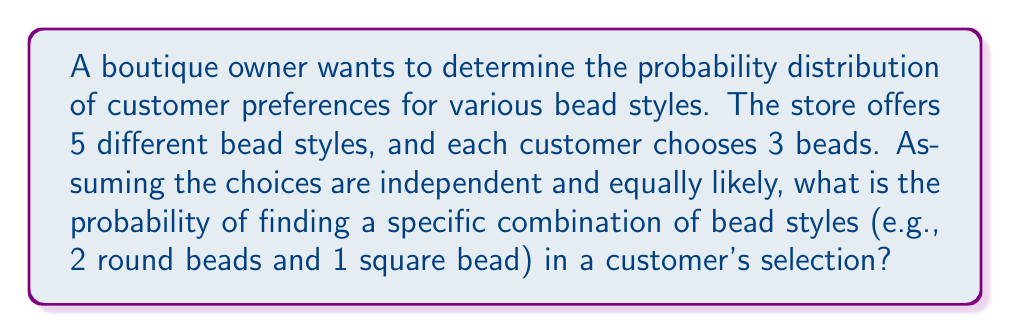Help me with this question. To solve this problem, we'll use concepts from statistical mechanics, specifically the multinomial distribution.

Step 1: Define the system
- Total number of bead styles: $N = 5$
- Number of beads chosen by each customer: $n = 3$

Step 2: Calculate the total number of possible combinations
The total number of ways to choose 3 beads from 5 styles with replacement is:
$$ \Omega = N^n = 5^3 = 125 $$

Step 3: Calculate the probability of a specific combination
For the example of 2 round beads and 1 square bead:
- Number of ways to arrange this combination: $\binom{3}{2,1} = \frac{3!}{2!1!} = 3$
- Probability of choosing each bead: $p_{\text{round}} = p_{\text{square}} = \frac{1}{5}$

The probability of this specific combination is:
$$ P = \binom{3}{2,1} \cdot \left(\frac{1}{5}\right)^2 \cdot \left(\frac{1}{5}\right)^1 \cdot 3 = \frac{3}{125} = 0.024 $$

Step 4: Generalize the formula
For any combination of bead styles $(n_1, n_2, ..., n_k)$ where $\sum_{i=1}^k n_i = n$:

$$ P = \frac{n!}{n_1! n_2! ... n_k!} \cdot \prod_{i=1}^k \left(\frac{1}{N}\right)^{n_i} $$

This formula represents the probability distribution of customer preferences for various bead styles using the multinomial distribution, which is an extension of the binomial distribution to multiple categories.
Answer: $P = \frac{n!}{n_1! n_2! ... n_k!} \cdot \prod_{i=1}^k \left(\frac{1}{N}\right)^{n_i}$ 